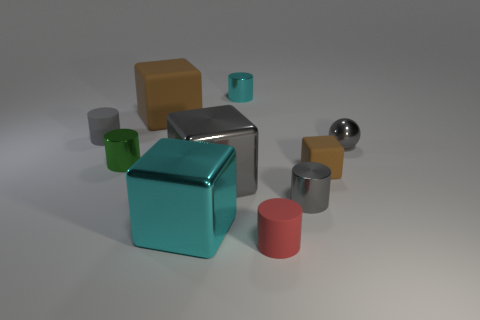What is the color of the matte thing that is to the right of the small red object that is in front of the green cylinder?
Your answer should be very brief. Brown. There is a small cylinder behind the brown thing that is behind the green cylinder that is in front of the big brown thing; what is it made of?
Your answer should be very brief. Metal. There is a cyan object that is in front of the gray rubber object; is it the same size as the gray shiny sphere?
Provide a short and direct response. No. What is the brown object right of the tiny cyan thing made of?
Your answer should be very brief. Rubber. Is the number of yellow matte blocks greater than the number of small red matte cylinders?
Provide a short and direct response. No. How many objects are tiny shiny objects that are right of the cyan shiny cylinder or small gray rubber things?
Your answer should be compact. 3. There is a small rubber thing in front of the tiny rubber cube; what number of rubber cylinders are on the left side of it?
Your answer should be very brief. 1. How big is the brown matte cube that is on the right side of the small cylinder that is on the right side of the red matte cylinder that is in front of the big brown cube?
Offer a very short reply. Small. Does the shiny cylinder that is in front of the small brown thing have the same color as the small sphere?
Offer a terse response. Yes. The cyan metallic object that is the same shape as the green object is what size?
Ensure brevity in your answer.  Small. 